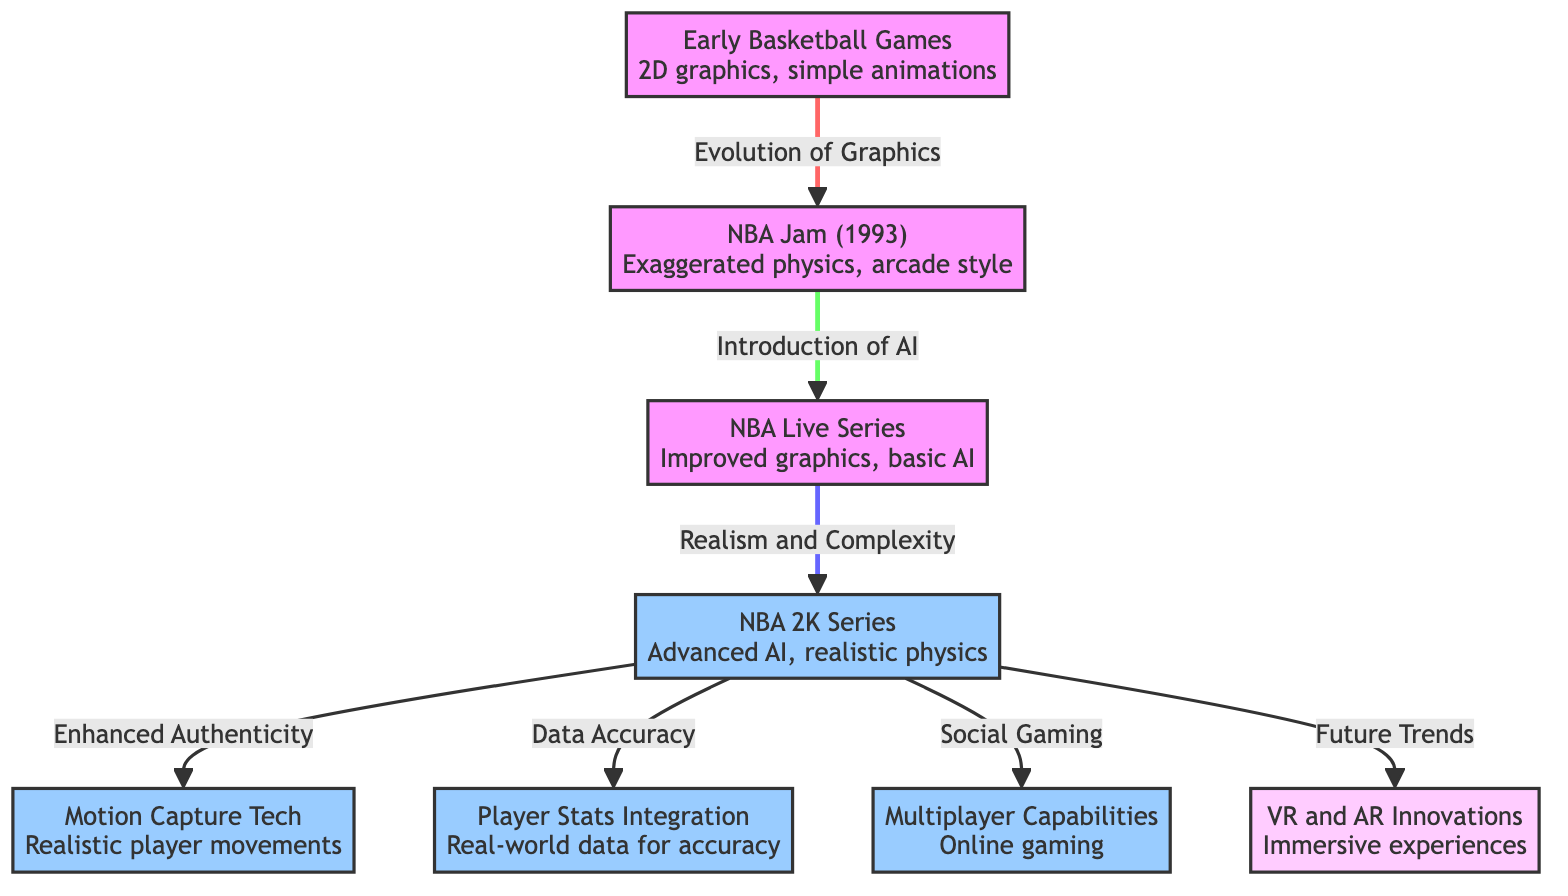What is the first node in the diagram? The first node is labeled "Early Basketball Games<br/>2D graphics, simple animations." It appears at the top of the diagram, indicating the starting point of the evolution of basketball mechanics.
Answer: Early Basketball Games<br/>2D graphics, simple animations How many nodes are listed under "NBA 2K Series"? Under "NBA 2K Series," there are three nodes listed: "Motion Capture Tech<br/>Realistic player movements," "Player Stats Integration<br/>Real-world data for accuracy," and "Multiplayer Capabilities<br/>Online gaming." Therefore, the total is three nodes.
Answer: 3 What is the relationship between "NBA Live Series" and "NBA 2K Series"? The "NBA Live Series" leads to "NBA 2K Series" with the label "Realism and Complexity," signifying a direct evolution from one series to the next, indicating an increase in realism within the game mechanics.
Answer: Realism and Complexity Which node represents the future trends in basketball gaming? The node representing future trends is labeled "VR and AR Innovations<br/>Immersive experiences." It is located at the end of the flow, suggesting it reflects the projected developments in basketball simulation games.
Answer: VR and AR Innovations<br/>Immersive experiences What are the two branches that extend from "NBA 2K Series"? The two branches extending from "NBA 2K Series" are "Enhanced Authenticity" and one branch leading to "Data Accuracy," "Social Gaming," and "Future Trends." Both branches illustrate different facets of the game's evolution.
Answer: Enhanced Authenticity, Data Accuracy, Social Gaming, Future Trends 